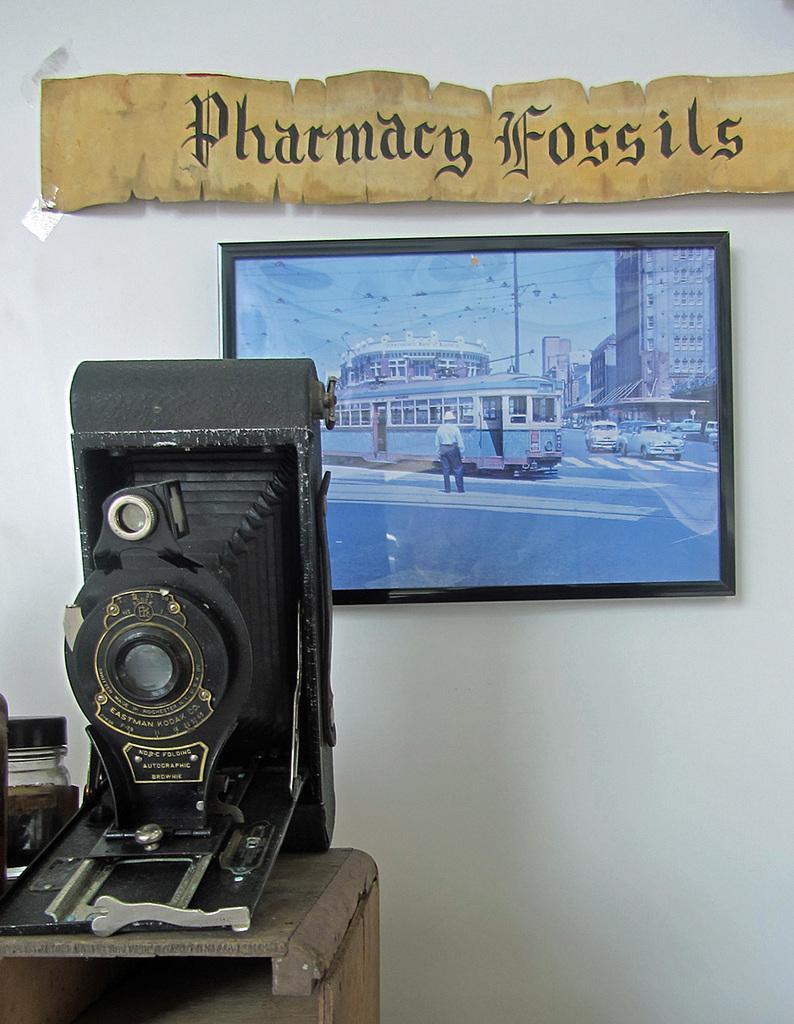How would you summarize this image in a sentence or two? Here we can see a camera, frame, and a board. On this frame we can see a person, vehicles, pole, and buildings. In the background there is a wall. 